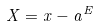<formula> <loc_0><loc_0><loc_500><loc_500>X = x - a ^ { E }</formula> 